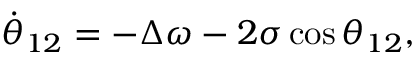Convert formula to latex. <formula><loc_0><loc_0><loc_500><loc_500>\dot { \theta } _ { 1 2 } = - \Delta \omega - 2 \sigma \cos \theta _ { 1 2 } ,</formula> 